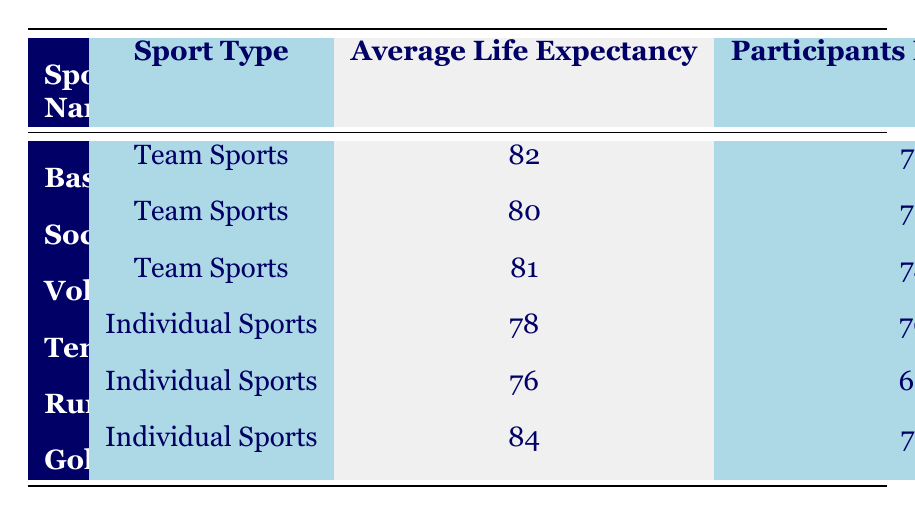What is the average life expectancy for team sports? To find the average life expectancy for team sports, we need to sum the average life expectancy of each team sport and divide by the number of team sports. (82 + 80 + 81) / 3 = 243 / 3 = 81
Answer: 81 Which individual sport has the highest average life expectancy? Looking at the individual sports, there are three entries: Tennis (78), Running (76), and Golf (84). The highest among these is Golf with an average life expectancy of 84.
Answer: Golf Is the average life expectancy for team sports generally higher than that of individual sports? The average life expectancy for team sports is calculated as 81 (as found earlier) and for individual sports is (78 + 76 + 84) / 3 = 238 / 3 = 79.33. Since 81 is greater than 79.33, this statement is true.
Answer: Yes What is the average health index for soccer and volleyball combined? To find this average, we take the health index for Soccer (72) and Volleyball (74), add them up, and divide by 2. Therefore, (72 + 74) / 2 = 146 / 2 = 73.
Answer: 73 Is the participants' health index for basketball higher than 70? The participants' health index for Basketball is 75, which is indeed higher than 70.
Answer: Yes Which sport has the lowest participants' health index? By examining the participants' health index values, we find that Running has the lowest value at 68 among all sports listed.
Answer: Running What is the difference in average life expectancy between the highest life expectancy sport and the lowest? The highest average life expectancy is Golf at 84 and the lowest is Running at 76. The difference is thus 84 - 76 = 8.
Answer: 8 What is the average life expectancy for sports with participants' health index of 75 or higher? We consider Basketball (82) and Golf (84) as they have health indexes of 75 and 77. The average is (82 + 84) / 2 = 166 / 2 = 83.
Answer: 83 